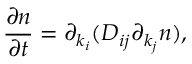<formula> <loc_0><loc_0><loc_500><loc_500>\frac { \partial n } { \partial t } = \partial _ { k _ { i } } ( D _ { i j } \partial _ { k _ { j } } n ) ,</formula> 